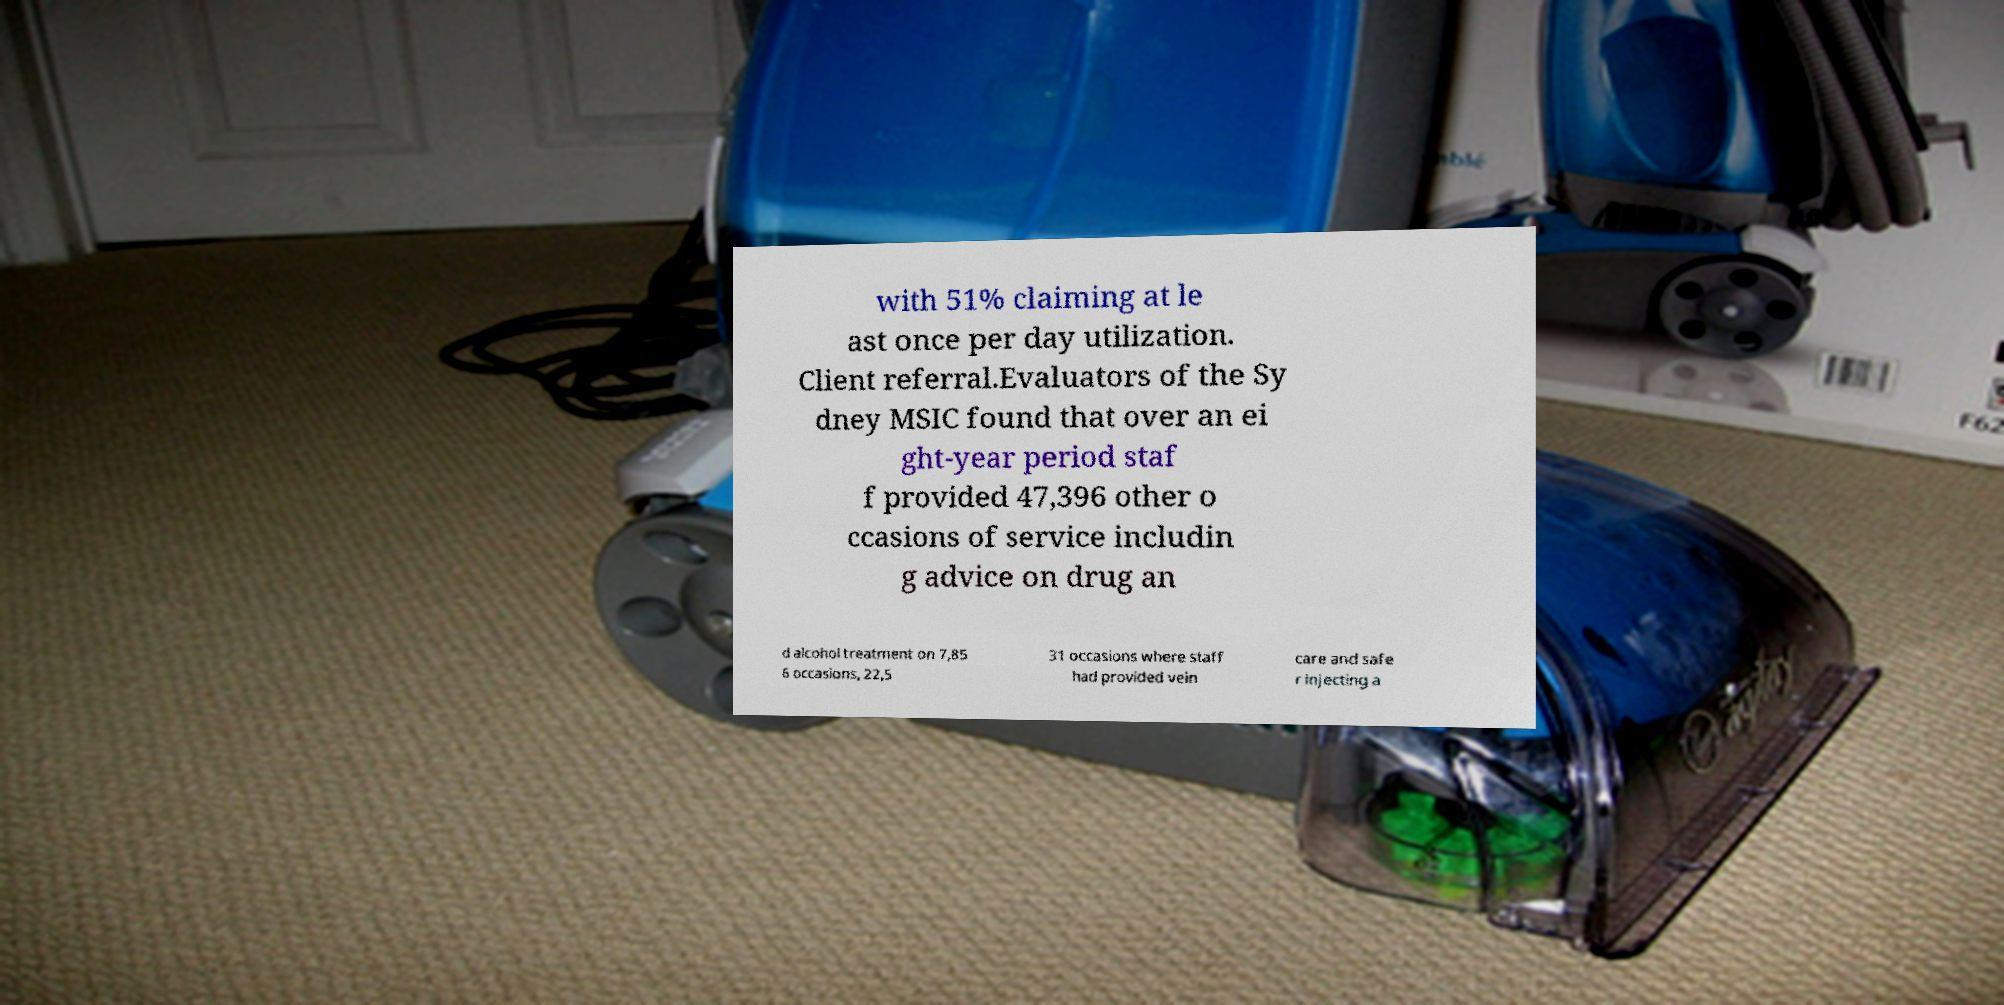Could you assist in decoding the text presented in this image and type it out clearly? with 51% claiming at le ast once per day utilization. Client referral.Evaluators of the Sy dney MSIC found that over an ei ght-year period staf f provided 47,396 other o ccasions of service includin g advice on drug an d alcohol treatment on 7,85 6 occasions, 22,5 31 occasions where staff had provided vein care and safe r injecting a 